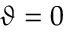Convert formula to latex. <formula><loc_0><loc_0><loc_500><loc_500>\vartheta = 0</formula> 